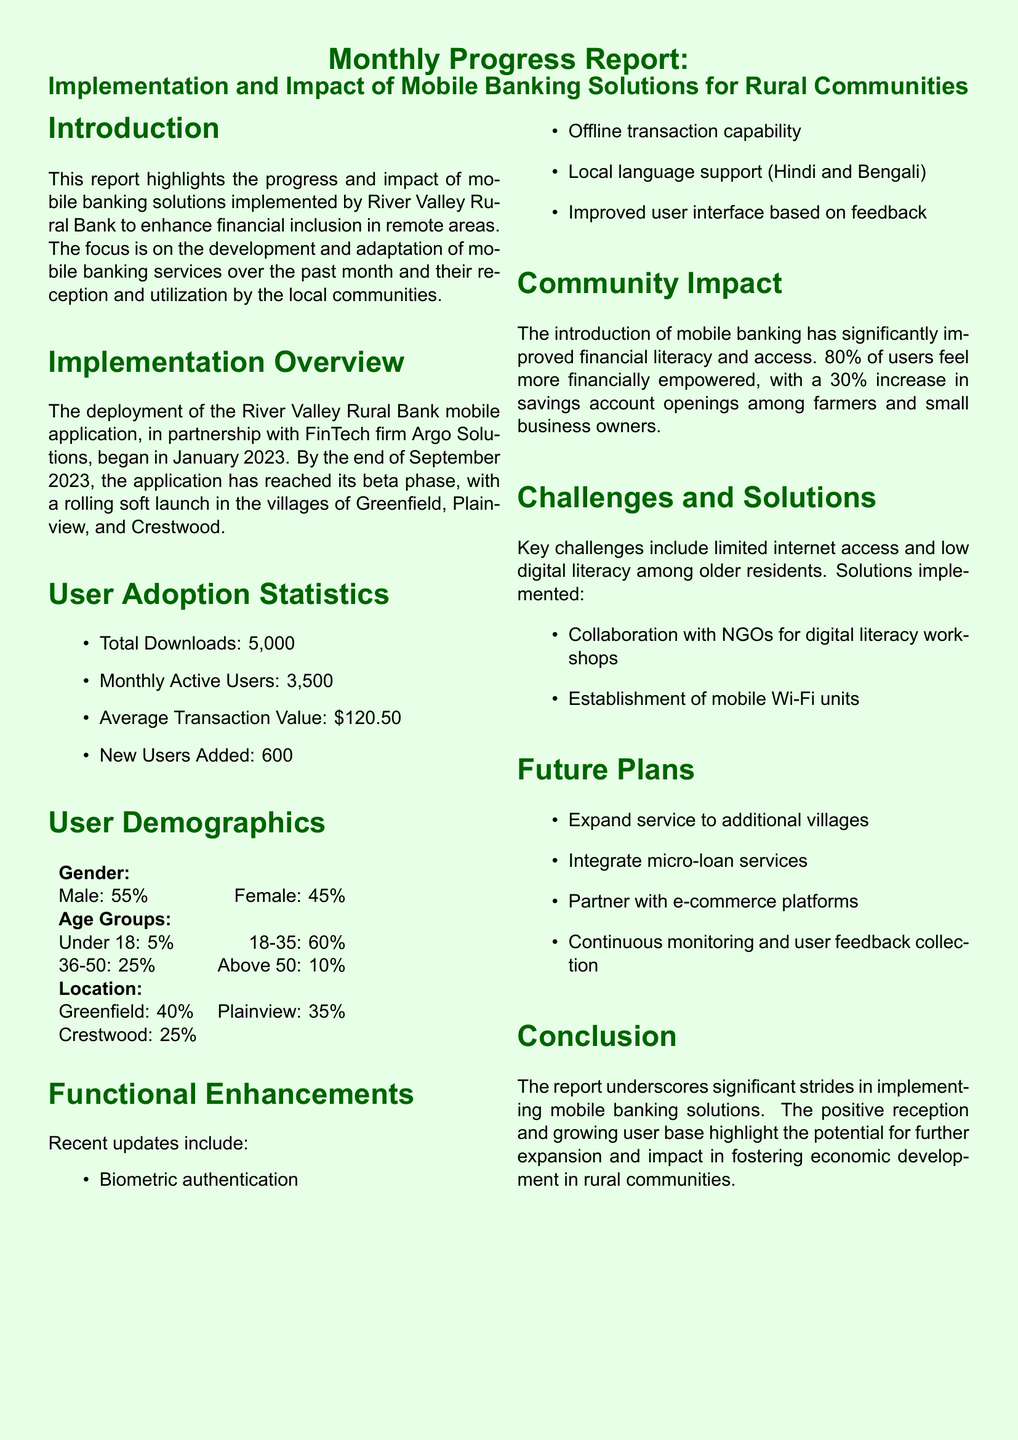What is the total number of downloads of the mobile application? The total downloads are mentioned under User Adoption Statistics, which states 5,000.
Answer: 5,000 What percentage of users feel more financially empowered? The report mentions that 80% of users feel more financially empowered under the Community Impact section.
Answer: 80% In which month did the mobile application deployment begin? The deployment of the mobile application began in January 2023, as stated in the Implementation Overview.
Answer: January 2023 What are the two local languages supported by the mobile app? The languages are listed under Functional Enhancements, specifically Hindi and Bengali.
Answer: Hindi and Bengali What percentage of users are in the age group 18-35? This demographic information is provided in the User Demographics section, stating 60% are aged 18-35.
Answer: 60% How has the savings account opening rate changed among farmers and small business owners? The Community Impact section notes a 30% increase in savings account openings among this group.
Answer: 30% What is one of the key challenges mentioned in the report? The report outlines limited internet access as a key challenge under Challenges and Solutions.
Answer: Limited internet access What is one future plan for the mobile banking service? Future plans are listed in the Future Plans section; one plan is to expand service to additional villages.
Answer: Expand service to additional villages 